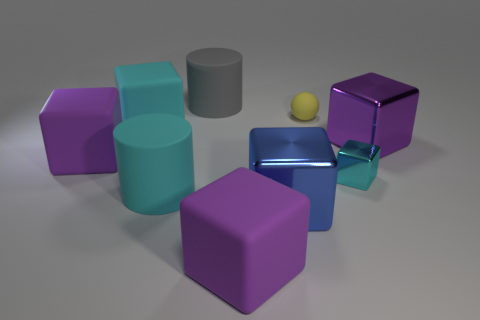Subtract all purple spheres. How many cyan blocks are left? 2 Subtract all cyan rubber blocks. How many blocks are left? 5 Subtract all blue blocks. How many blocks are left? 5 Add 1 red cubes. How many objects exist? 10 Subtract all gray blocks. Subtract all gray cylinders. How many blocks are left? 6 Subtract all balls. How many objects are left? 8 Add 9 tiny yellow blocks. How many tiny yellow blocks exist? 9 Subtract 0 brown cylinders. How many objects are left? 9 Subtract all small cyan metallic cubes. Subtract all cyan matte cubes. How many objects are left? 7 Add 7 tiny blocks. How many tiny blocks are left? 8 